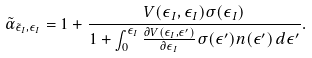Convert formula to latex. <formula><loc_0><loc_0><loc_500><loc_500>\tilde { \alpha } _ { \tilde { \epsilon } _ { I } , \epsilon _ { I } } = 1 + \frac { V ( \epsilon _ { I } , \epsilon _ { I } ) \sigma ( \epsilon _ { I } ) } { 1 + \int _ { 0 } ^ { \epsilon _ { I } } \frac { \partial V ( \epsilon _ { I } , \epsilon ^ { \prime } ) } { \partial \epsilon _ { I } } \sigma ( \epsilon ^ { \prime } ) n ( \epsilon ^ { \prime } ) \, d \epsilon ^ { \prime } } .</formula> 